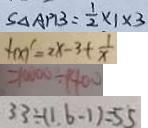Convert formula to latex. <formula><loc_0><loc_0><loc_500><loc_500>S _ { \Delta A P B } = \frac { 1 } { 2 } \times 1 \times 3 
 f ( x ) ^ { \prime } = 2 x - 3 + \frac { 1 } { x } 
 = 1 0 0 0 0 \div 1 4 0 0 
 3 3 \div ( 1 . 6 - 1 ) = 5 5</formula> 